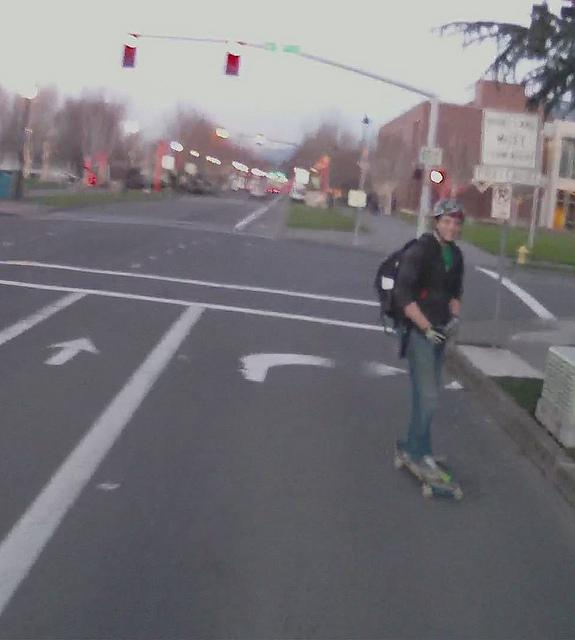A car turning which way is a hazard to this man? right 